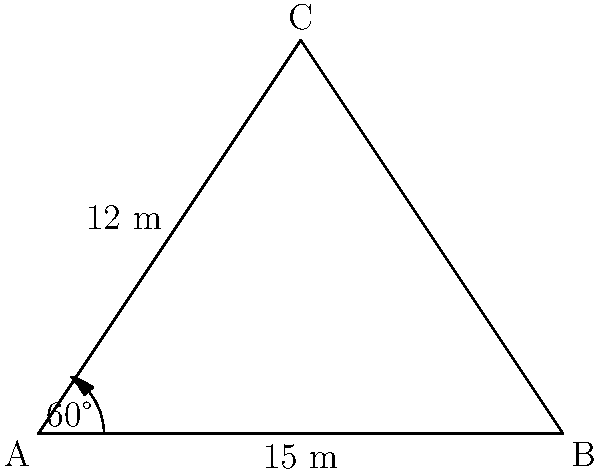In a rural area of Mauritius, a triangular plot of land needs to be surveyed for a new agricultural project. Two sides of the plot measure 15 meters and 12 meters, with an included angle of 60°. Calculate the area of this triangular plot of land to the nearest square meter. To solve this problem, we'll use the formula for the area of a triangle given two sides and the included angle:

$$ A = \frac{1}{2} ab \sin C $$

Where:
$A$ is the area of the triangle
$a$ and $b$ are the lengths of the two known sides
$C$ is the included angle

Step 1: Identify the given values
$a = 15$ m
$b = 12$ m
$C = 60°$

Step 2: Substitute these values into the formula
$$ A = \frac{1}{2} \cdot 15 \cdot 12 \cdot \sin 60° $$

Step 3: Calculate $\sin 60°$
$\sin 60° = \frac{\sqrt{3}}{2} \approx 0.866$

Step 4: Compute the area
$$ A = \frac{1}{2} \cdot 15 \cdot 12 \cdot 0.866 $$
$$ A = 77.94 \text{ m}^2 $$

Step 5: Round to the nearest square meter
$A \approx 78 \text{ m}^2$

Therefore, the area of the triangular plot of land is approximately 78 square meters.
Answer: 78 m² 